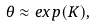Convert formula to latex. <formula><loc_0><loc_0><loc_500><loc_500>\theta \approx e x p ( K ) ,</formula> 